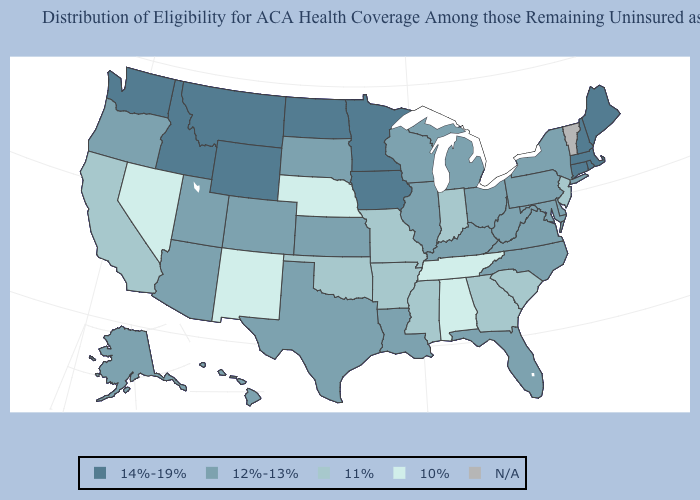Does West Virginia have the highest value in the South?
Keep it brief. Yes. Which states have the lowest value in the Northeast?
Keep it brief. New Jersey. What is the value of Illinois?
Short answer required. 12%-13%. Name the states that have a value in the range 12%-13%?
Write a very short answer. Alaska, Arizona, Colorado, Delaware, Florida, Hawaii, Illinois, Kansas, Kentucky, Louisiana, Maryland, Michigan, New York, North Carolina, Ohio, Oregon, Pennsylvania, South Dakota, Texas, Utah, Virginia, West Virginia, Wisconsin. Among the states that border Florida , which have the highest value?
Concise answer only. Georgia. Name the states that have a value in the range N/A?
Be succinct. Vermont. Does the first symbol in the legend represent the smallest category?
Keep it brief. No. How many symbols are there in the legend?
Answer briefly. 5. Which states have the highest value in the USA?
Answer briefly. Connecticut, Idaho, Iowa, Maine, Massachusetts, Minnesota, Montana, New Hampshire, North Dakota, Rhode Island, Washington, Wyoming. What is the value of New Hampshire?
Answer briefly. 14%-19%. What is the value of Washington?
Be succinct. 14%-19%. Name the states that have a value in the range 12%-13%?
Be succinct. Alaska, Arizona, Colorado, Delaware, Florida, Hawaii, Illinois, Kansas, Kentucky, Louisiana, Maryland, Michigan, New York, North Carolina, Ohio, Oregon, Pennsylvania, South Dakota, Texas, Utah, Virginia, West Virginia, Wisconsin. Does Connecticut have the lowest value in the USA?
Concise answer only. No. Does Georgia have the highest value in the South?
Be succinct. No. Name the states that have a value in the range 10%?
Be succinct. Alabama, Nebraska, Nevada, New Mexico, Tennessee. 